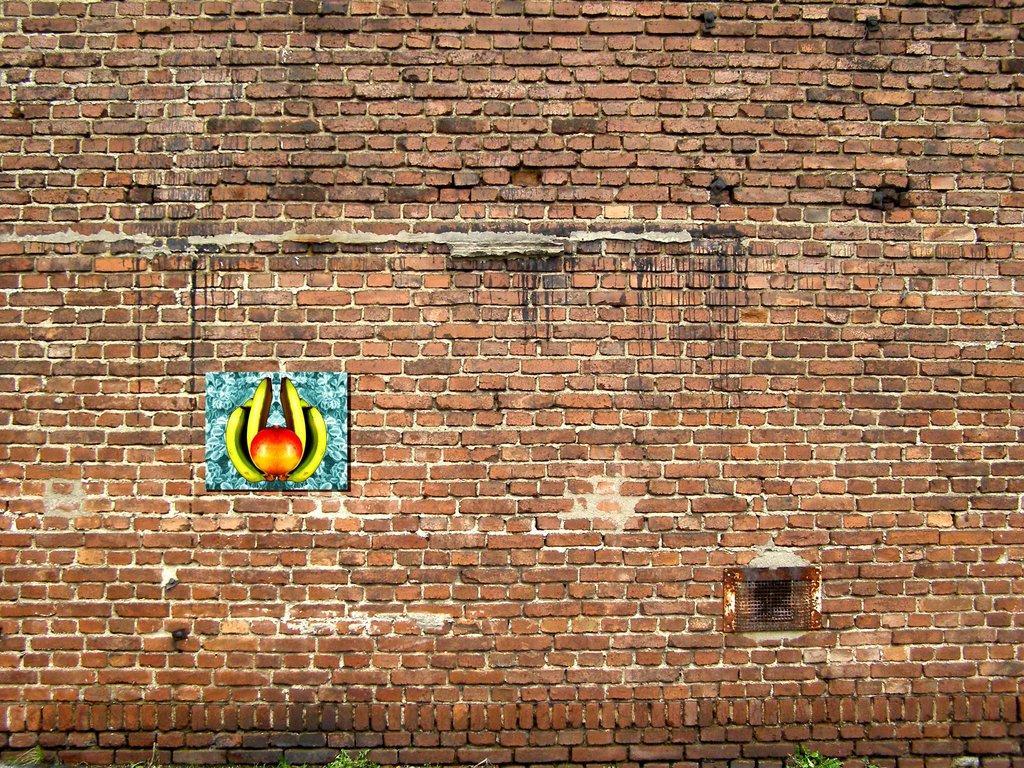Can you describe this image briefly? In this picture we can see a board and mesh are present on the brick wall. At the bottom of the image we can see the plants. 